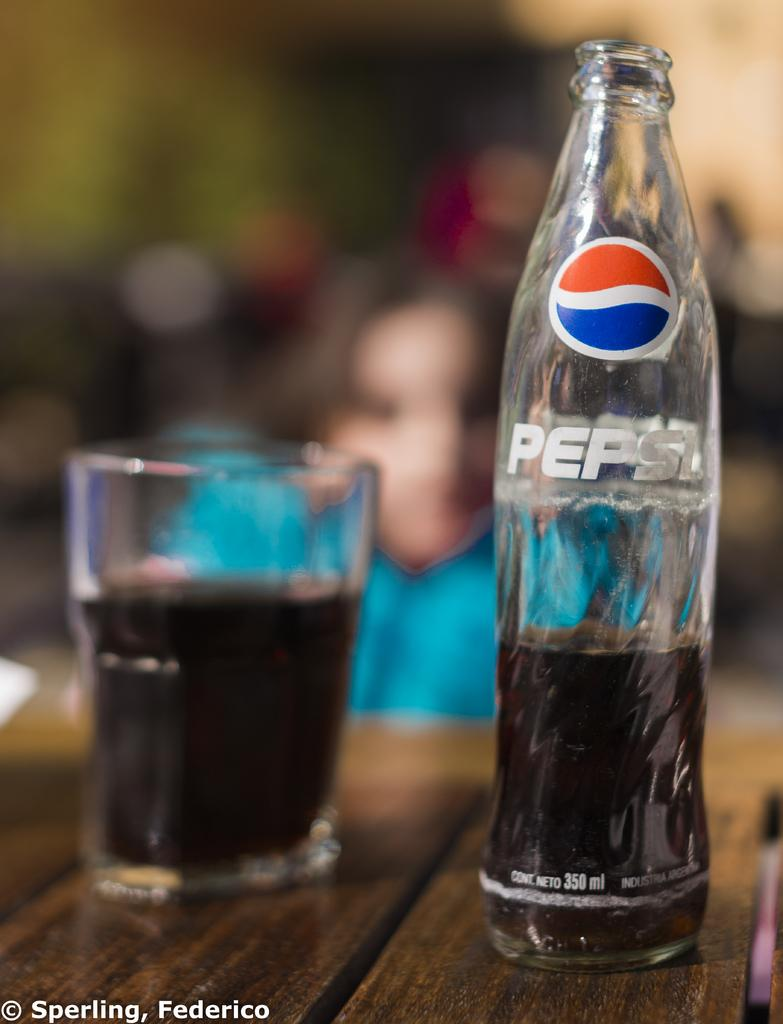<image>
Summarize the visual content of the image. A bottle of Pepsi is on a table next to a glass. 